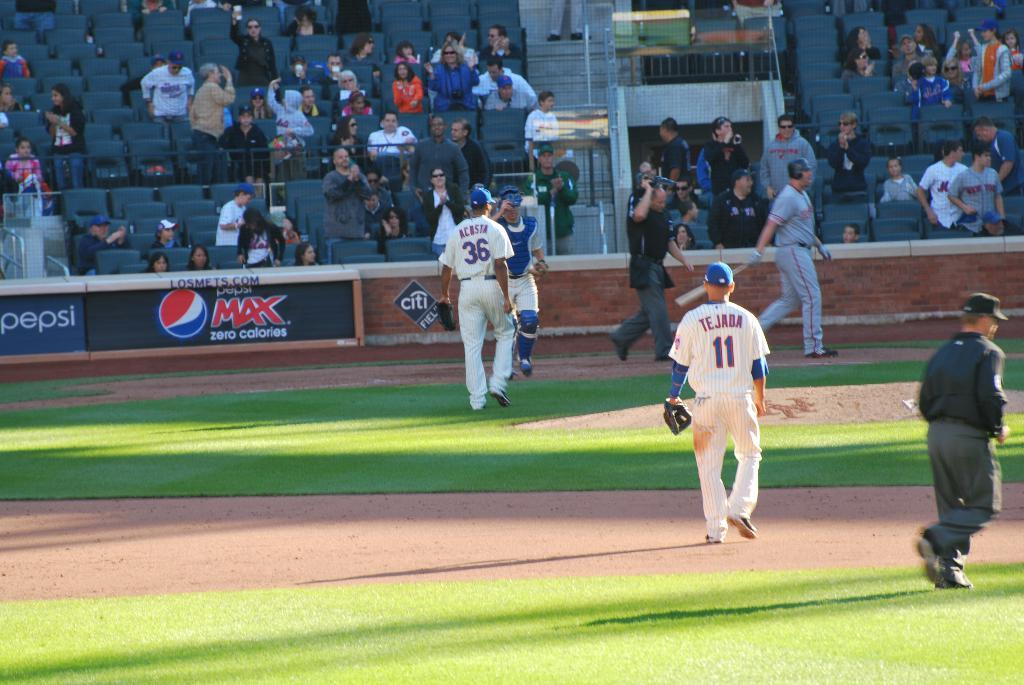<image>
Describe the image concisely. Baseball players Acosta and Tejada on the playing field at Citi Field. 